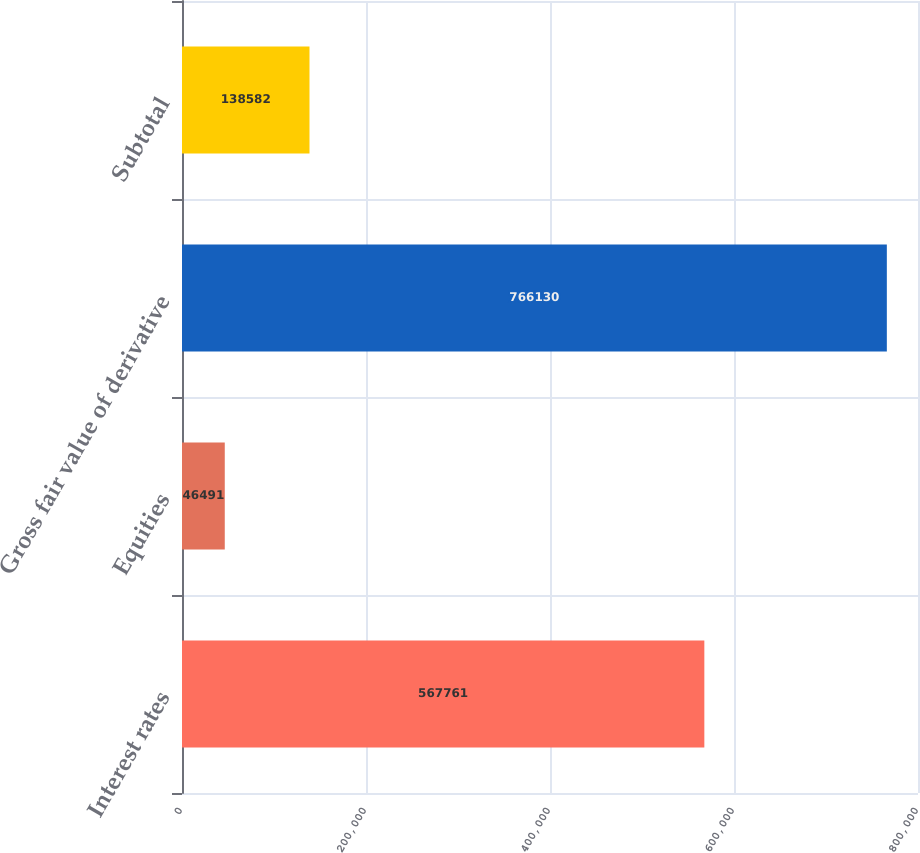Convert chart. <chart><loc_0><loc_0><loc_500><loc_500><bar_chart><fcel>Interest rates<fcel>Equities<fcel>Gross fair value of derivative<fcel>Subtotal<nl><fcel>567761<fcel>46491<fcel>766130<fcel>138582<nl></chart> 